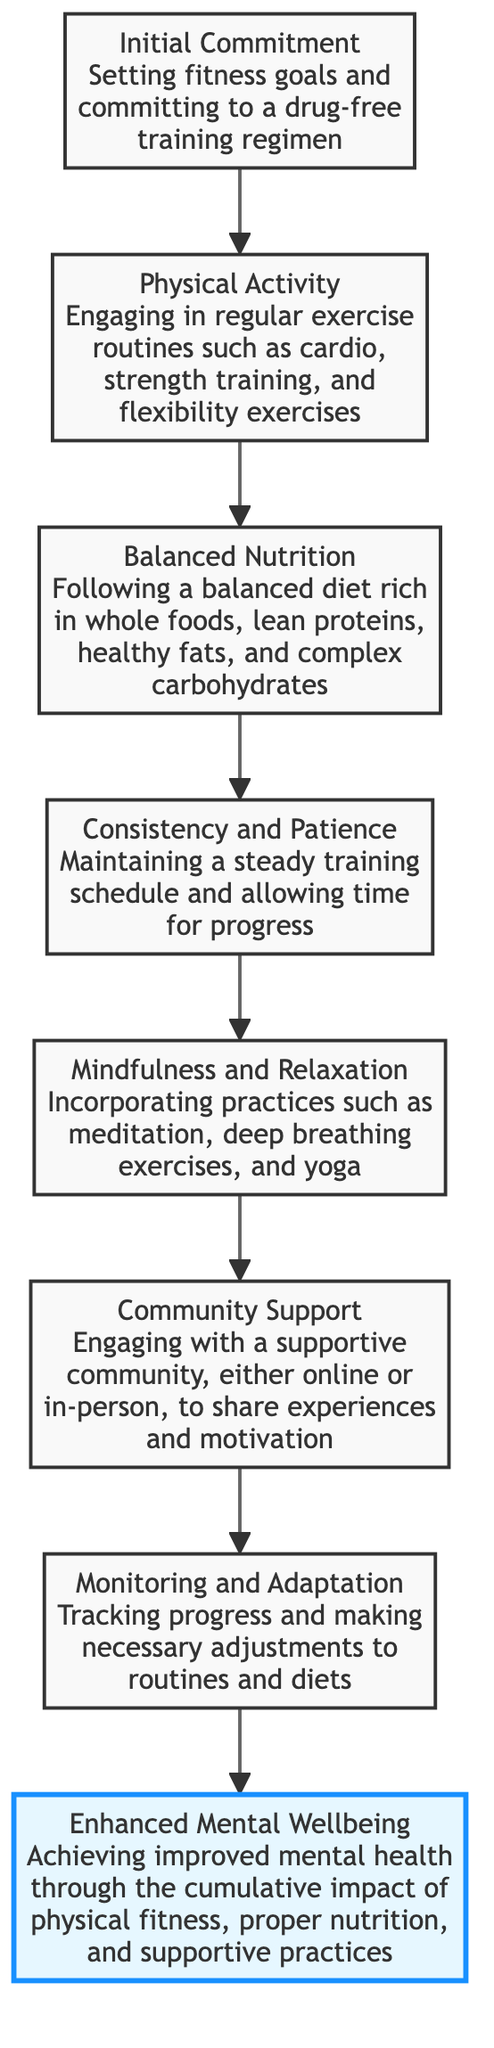What is the title of the first level in the diagram? The first element in the diagram is titled "Initial Commitment," which is located at the bottom (level 1) according to the flow order.
Answer: Initial Commitment How many levels are there in the diagram? The diagram consists of eight levels, starting from "Initial Commitment" at the bottom and ending with "Enhanced Mental Wellbeing" at the top.
Answer: 8 What does the final level represent? The final level is titled "Enhanced Mental Wellbeing" and represents the ultimate goal achieved by following the steps outlined in the diagram.
Answer: Enhanced Mental Wellbeing What step follows "Balanced Nutrition"? The step that follows "Balanced Nutrition" is "Consistency and Patience," showing the progression in the workflow from one level to the next.
Answer: Consistency and Patience What supports the process of achieving "Enhanced Mental Wellbeing"? "Community Support" is identified as a crucial factor that helps sustain the journey toward achieving "Enhanced Mental Wellbeing."
Answer: Community Support What two practices are included under "Mindfulness and Relaxation"? The practices mentioned under "Mindfulness and Relaxation" include "meditation" and "deep breathing exercises," which are both aimed at enhancing mental wellness.
Answer: meditation, deep breathing exercises How many direct connections does "Monitoring and Adaptation" have? "Monitoring and Adaptation" has one direct connection leading to "Enhanced Mental Wellbeing," indicating its importance in the final outcome.
Answer: 1 Which step is characterized by the need for "Consistency and Patience"? The step characterized by the need for "Consistency and Patience" is identified as the fourth level following "Balanced Nutrition." This shows a structured approach toward reaching mental wellness.
Answer: Consistency and Patience At what level is "Balanced Nutrition" found in the diagram? "Balanced Nutrition" is located at level 3 within the hierarchy of the diagram, illustrating its role in the path to mental wellness.
Answer: Level 3 